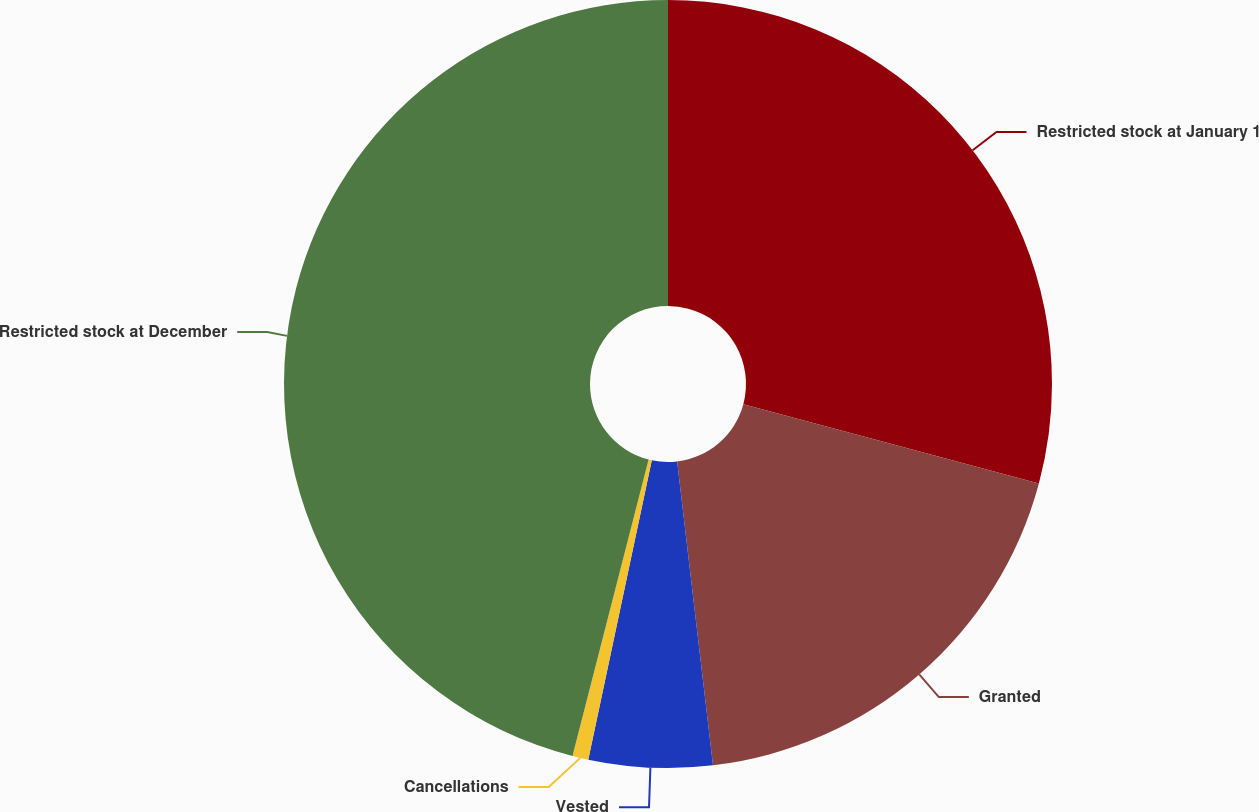Convert chart to OTSL. <chart><loc_0><loc_0><loc_500><loc_500><pie_chart><fcel>Restricted stock at January 1<fcel>Granted<fcel>Vested<fcel>Cancellations<fcel>Restricted stock at December<nl><fcel>29.17%<fcel>18.96%<fcel>5.2%<fcel>0.67%<fcel>46.0%<nl></chart> 